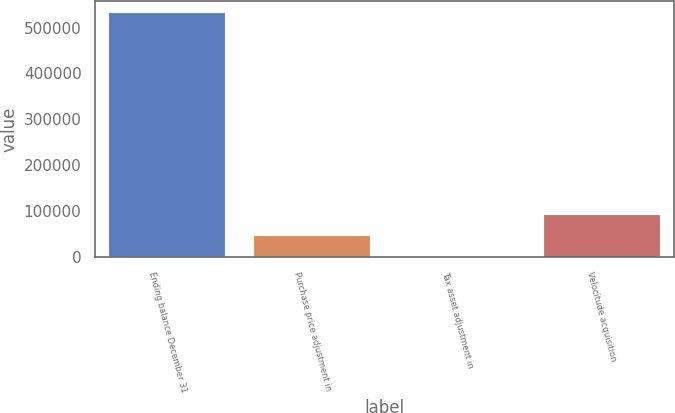Convert chart. <chart><loc_0><loc_0><loc_500><loc_500><bar_chart><fcel>Ending balance December 31<fcel>Purchase price adjustment in<fcel>Tax asset adjustment in<fcel>Velocitude acquisition<nl><fcel>531735<fcel>45766.6<fcel>528<fcel>91005.2<nl></chart> 